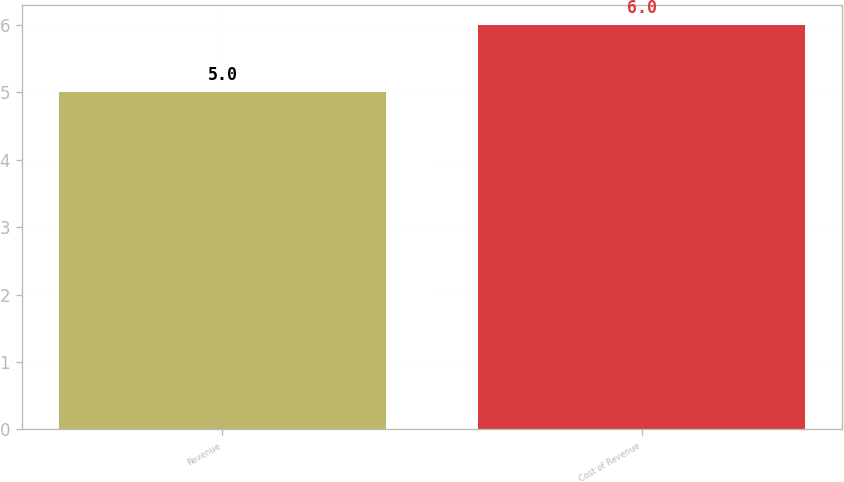<chart> <loc_0><loc_0><loc_500><loc_500><bar_chart><fcel>Revenue<fcel>Cost of Revenue<nl><fcel>5<fcel>6<nl></chart> 